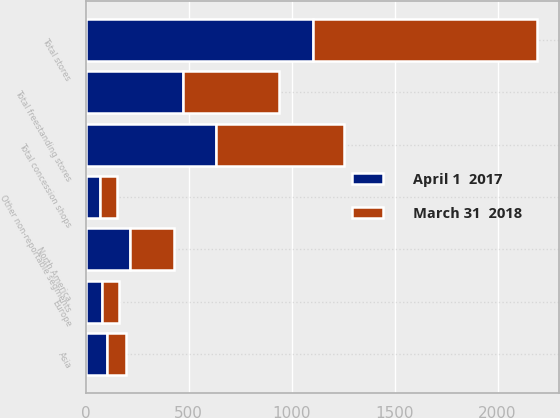Convert chart to OTSL. <chart><loc_0><loc_0><loc_500><loc_500><stacked_bar_chart><ecel><fcel>North America<fcel>Europe<fcel>Asia<fcel>Other non-reportable segments<fcel>Total freestanding stores<fcel>Total concession shops<fcel>Total stores<nl><fcel>April 1  2017<fcel>215<fcel>81<fcel>105<fcel>71<fcel>472<fcel>632<fcel>1104<nl><fcel>March 31  2018<fcel>216<fcel>82<fcel>89<fcel>79<fcel>466<fcel>620<fcel>1086<nl></chart> 